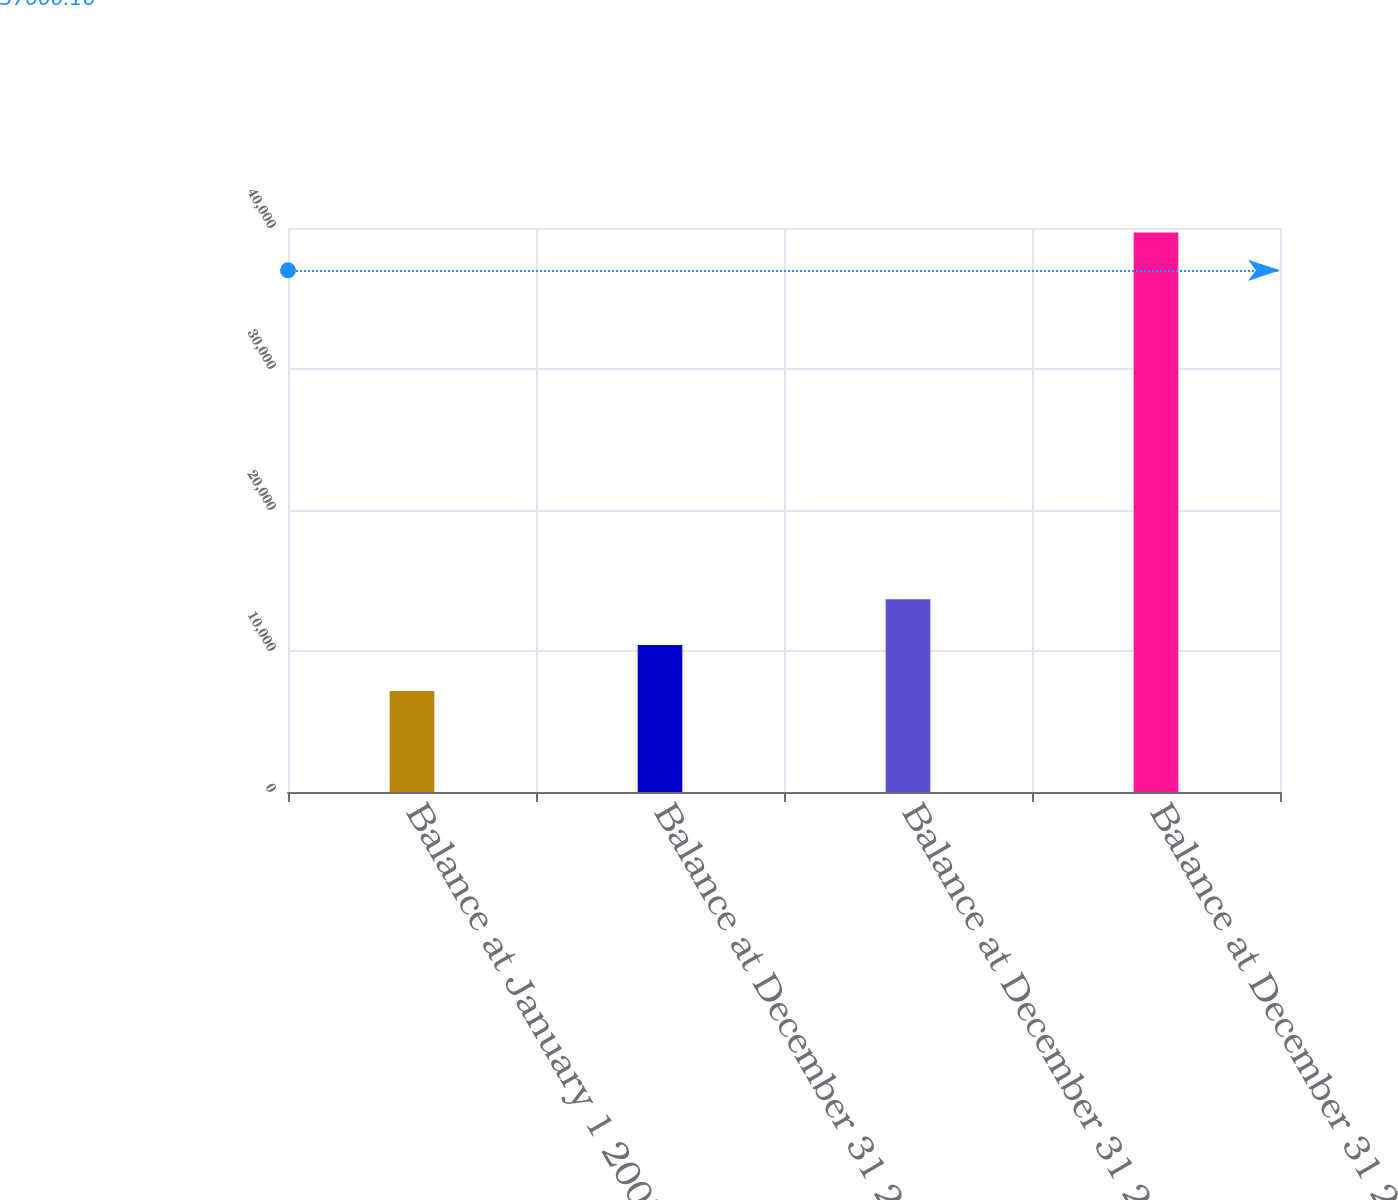<chart> <loc_0><loc_0><loc_500><loc_500><bar_chart><fcel>Balance at January 1 2007<fcel>Balance at December 31 2007<fcel>Balance at December 31 2008<fcel>Balance at December 31 2009<nl><fcel>7166.5<fcel>10418.1<fcel>13669.7<fcel>39682.6<nl></chart> 